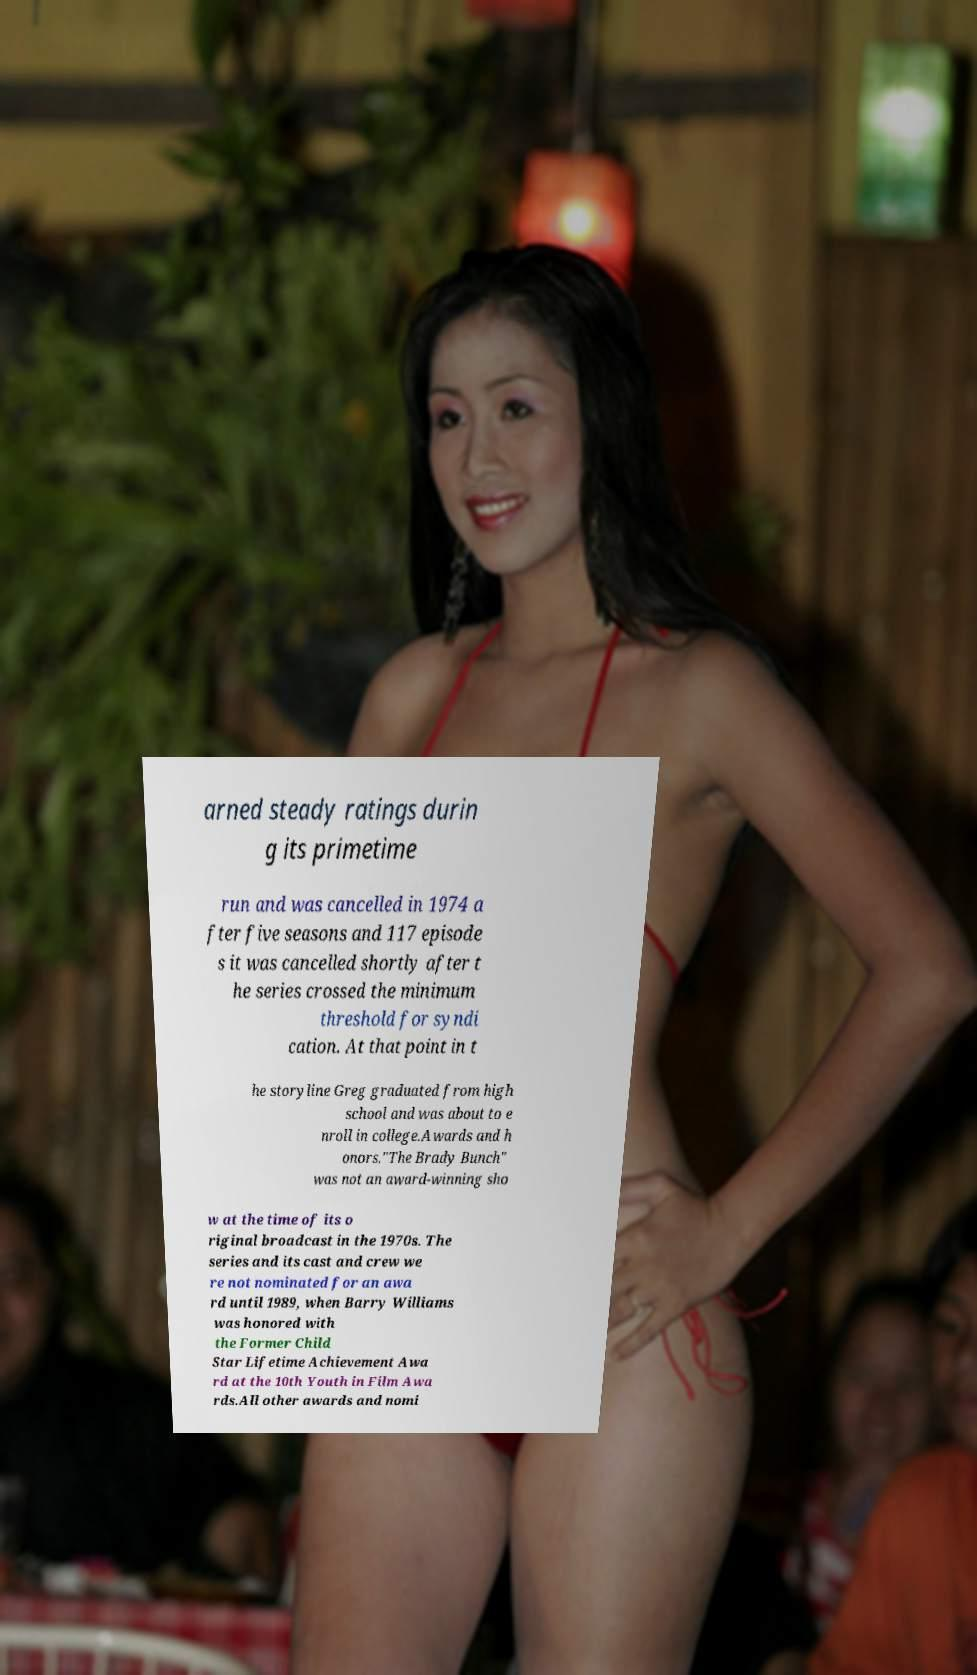I need the written content from this picture converted into text. Can you do that? arned steady ratings durin g its primetime run and was cancelled in 1974 a fter five seasons and 117 episode s it was cancelled shortly after t he series crossed the minimum threshold for syndi cation. At that point in t he storyline Greg graduated from high school and was about to e nroll in college.Awards and h onors."The Brady Bunch" was not an award-winning sho w at the time of its o riginal broadcast in the 1970s. The series and its cast and crew we re not nominated for an awa rd until 1989, when Barry Williams was honored with the Former Child Star Lifetime Achievement Awa rd at the 10th Youth in Film Awa rds.All other awards and nomi 